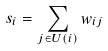Convert formula to latex. <formula><loc_0><loc_0><loc_500><loc_500>s _ { i } = \sum _ { j \in U ( i ) } w _ { i j }</formula> 